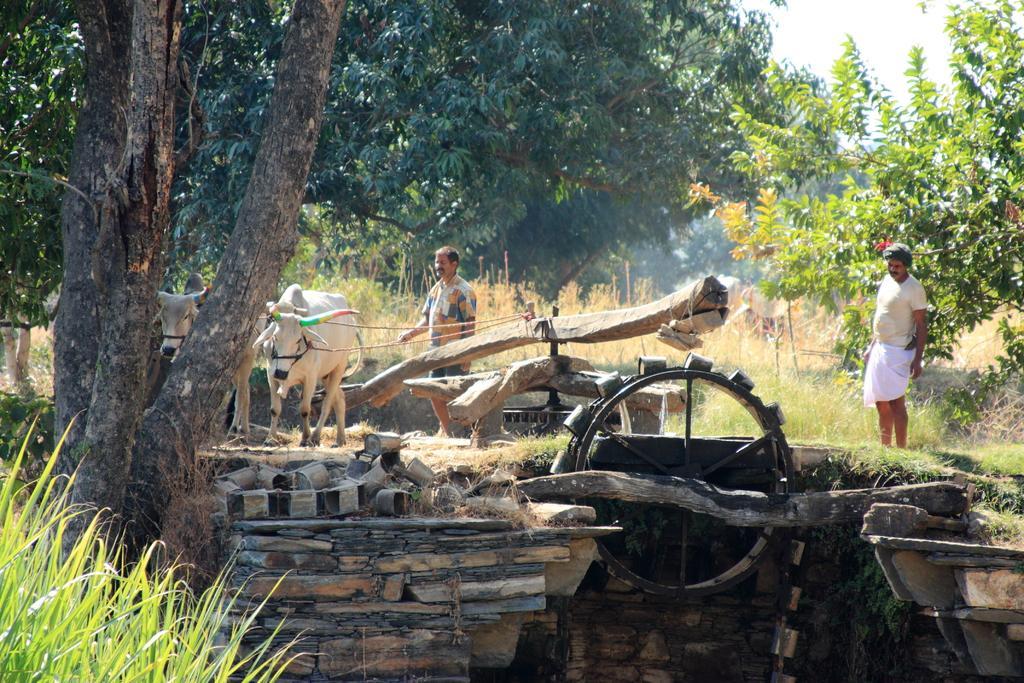Could you give a brief overview of what you see in this image? In the center of the image we can see logs, wheel, cows and two persons are standing. In the background of the image we can see the trees, grass, wall. In the top right corner we can see the sky. 